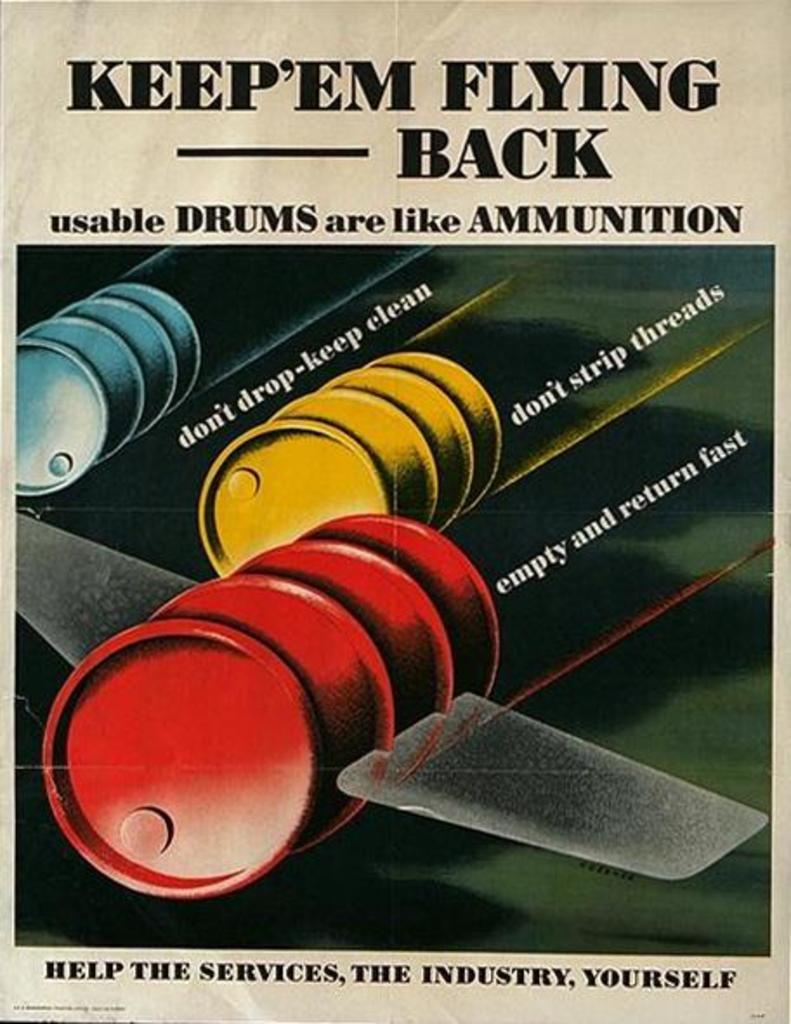<image>
Relay a brief, clear account of the picture shown. A flyer with oil barrels that have wings and says Keep`em Flying Back. 